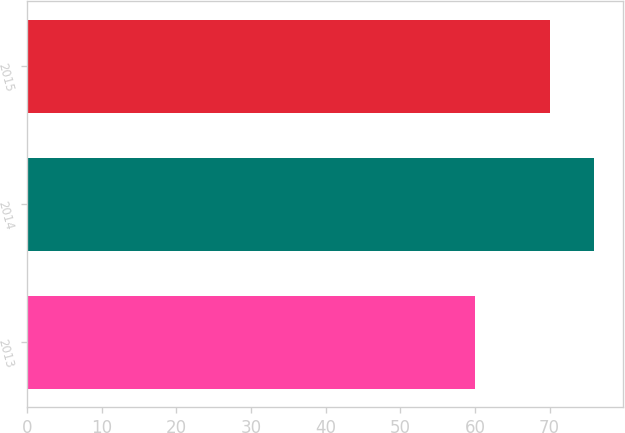Convert chart to OTSL. <chart><loc_0><loc_0><loc_500><loc_500><bar_chart><fcel>2013<fcel>2014<fcel>2015<nl><fcel>60<fcel>76<fcel>70<nl></chart> 